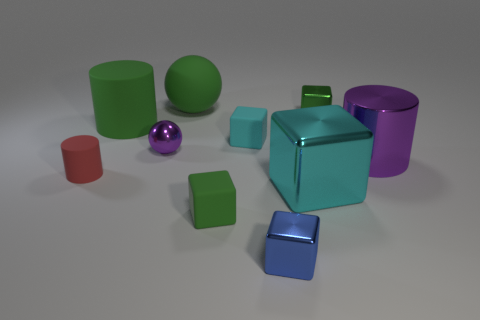Subtract all red cubes. Subtract all yellow cylinders. How many cubes are left? 5 Subtract all spheres. How many objects are left? 8 Add 4 green rubber spheres. How many green rubber spheres are left? 5 Add 3 blue matte cylinders. How many blue matte cylinders exist? 3 Subtract 0 gray cubes. How many objects are left? 10 Subtract all tiny metal spheres. Subtract all big red rubber things. How many objects are left? 9 